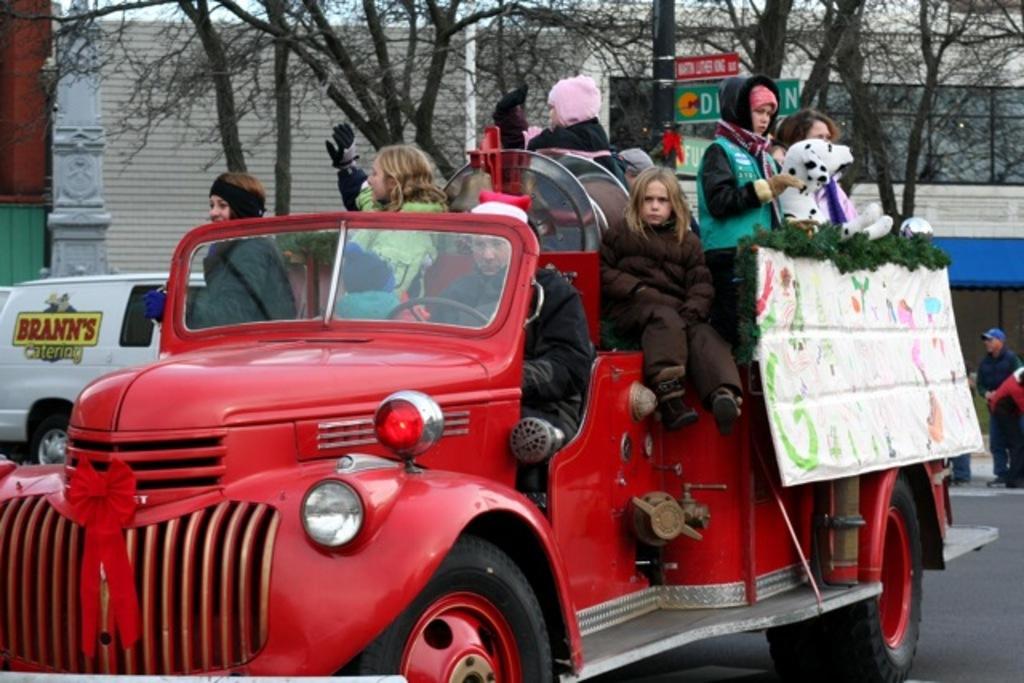In one or two sentences, can you explain what this image depicts? In this image I can see a red vehicle and people are present on it. There is a white dog and a board. There are trees, sign boards and buildings at the back. 